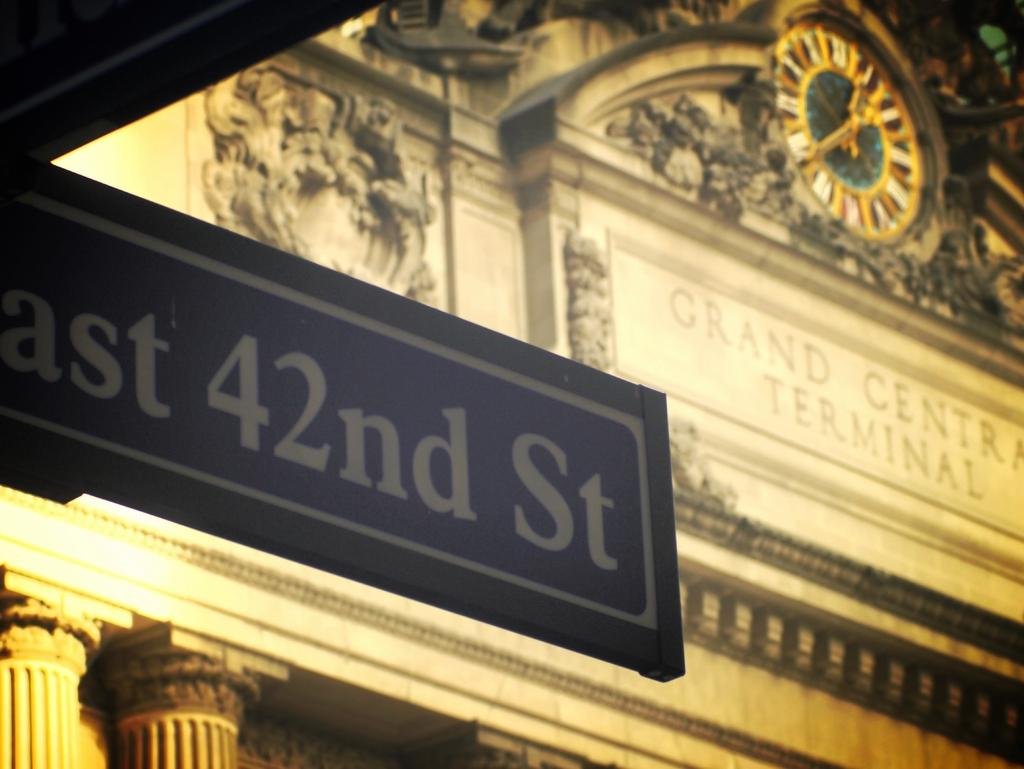<image>
Share a concise interpretation of the image provided. Before a ornate building, a street sign reads East 42nd street. 